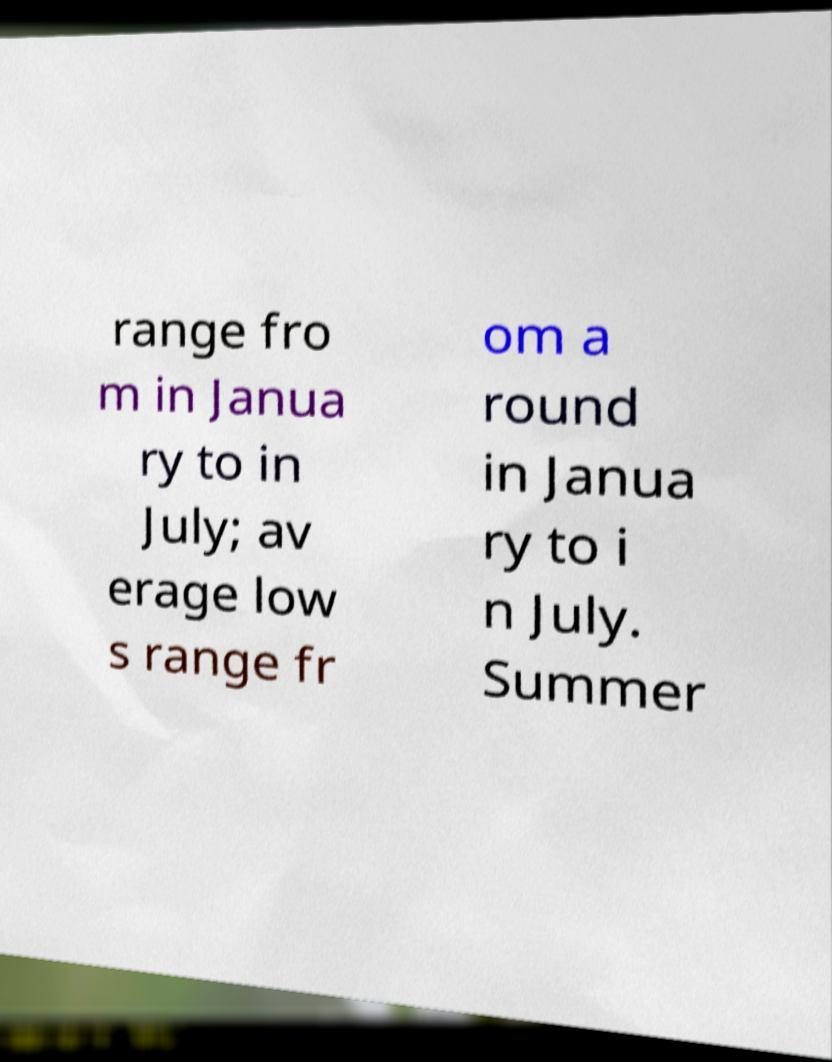Can you accurately transcribe the text from the provided image for me? range fro m in Janua ry to in July; av erage low s range fr om a round in Janua ry to i n July. Summer 